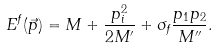<formula> <loc_0><loc_0><loc_500><loc_500>E ^ { f } ( \vec { p } ) = M + \frac { p _ { i } ^ { 2 } } { 2 M ^ { \prime } } + \sigma _ { f } \frac { p _ { 1 } p _ { 2 } } { M ^ { \prime \prime } } .</formula> 